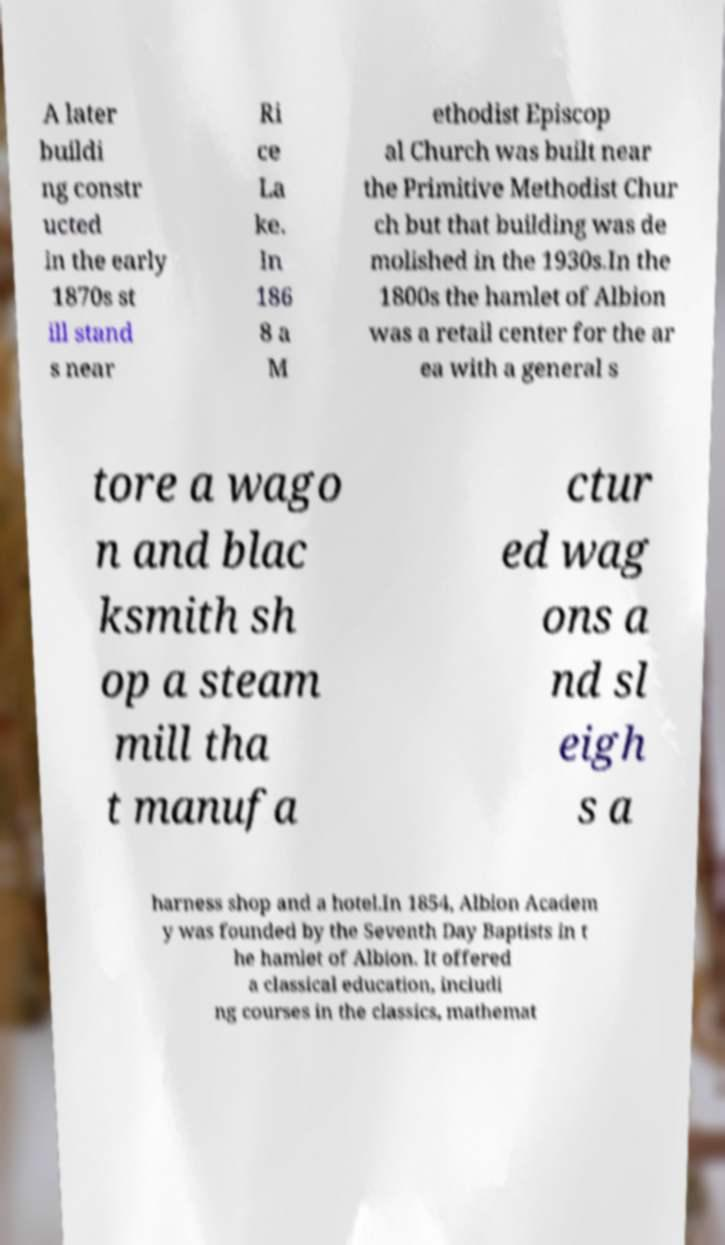Could you assist in decoding the text presented in this image and type it out clearly? A later buildi ng constr ucted in the early 1870s st ill stand s near Ri ce La ke. In 186 8 a M ethodist Episcop al Church was built near the Primitive Methodist Chur ch but that building was de molished in the 1930s.In the 1800s the hamlet of Albion was a retail center for the ar ea with a general s tore a wago n and blac ksmith sh op a steam mill tha t manufa ctur ed wag ons a nd sl eigh s a harness shop and a hotel.In 1854, Albion Academ y was founded by the Seventh Day Baptists in t he hamlet of Albion. It offered a classical education, includi ng courses in the classics, mathemat 